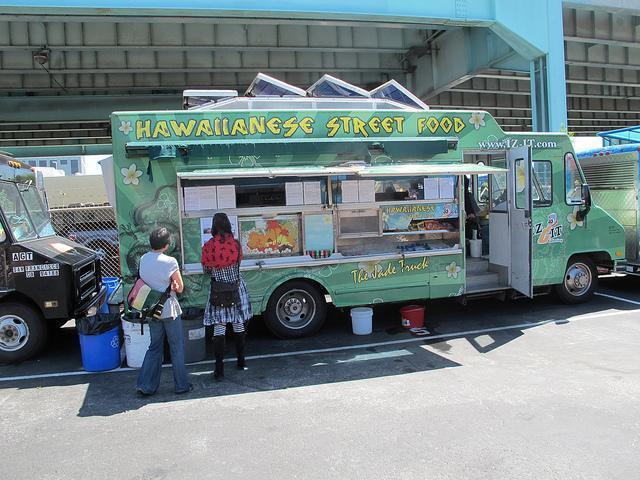How many people are waiting?
Give a very brief answer. 2. How many people are there?
Give a very brief answer. 2. How many trucks can you see?
Give a very brief answer. 2. How many dark umbrellas are there?
Give a very brief answer. 0. 